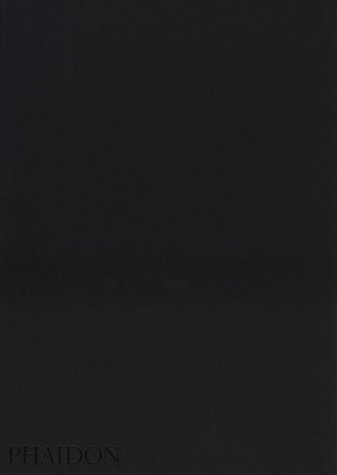Is this book related to Humor & Entertainment? No, this book is not related to the 'Humor & Entertainment' category. It primarily focuses on the cultural and religious aspects of the Mennonite community. 